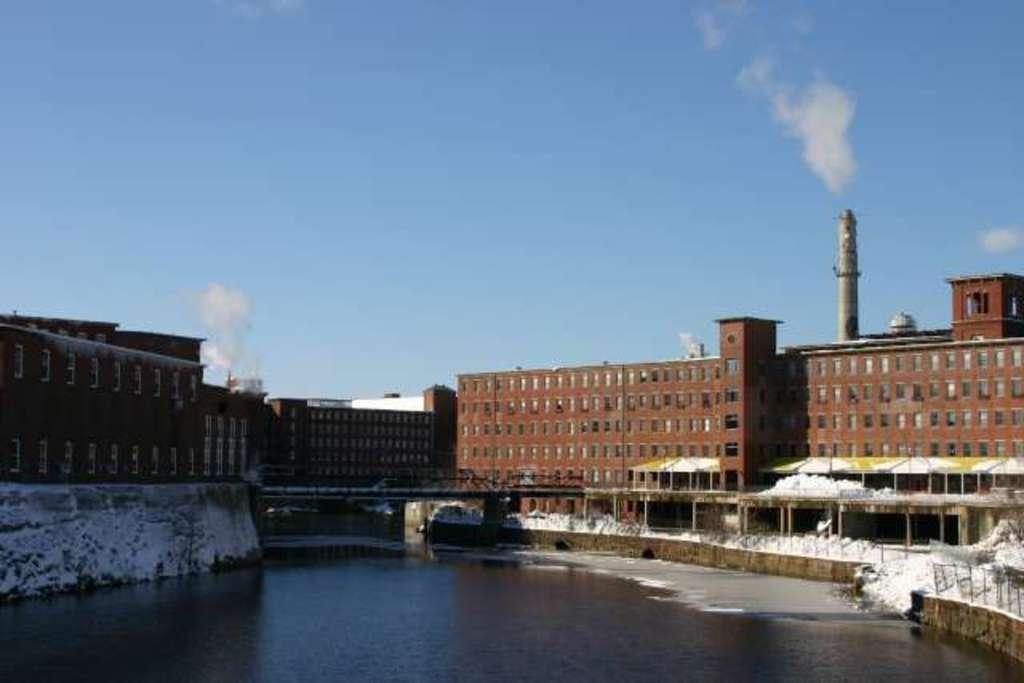What is the primary element present in the image? There is water in the image. What structure can be seen crossing over the water? There is a bridge in the image. What type of man-made structures are visible in the image? There are buildings in the image. What color is the stocking worn by the maid in the image? There is no maid or stocking present in the image. How many times does the person in the image laugh? There is no person laughing in the image, as it primarily features water, a bridge, and buildings. 